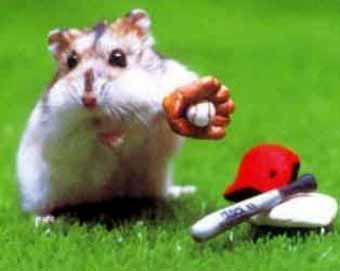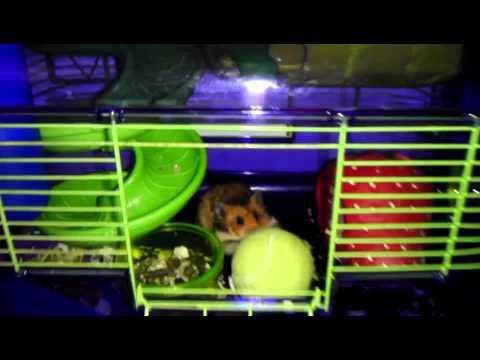The first image is the image on the left, the second image is the image on the right. Analyze the images presented: Is the assertion "A small rodent is holding a tennis racket." valid? Answer yes or no. No. The first image is the image on the left, the second image is the image on the right. Assess this claim about the two images: "There is a hamster holding a tennis racket.". Correct or not? Answer yes or no. No. 